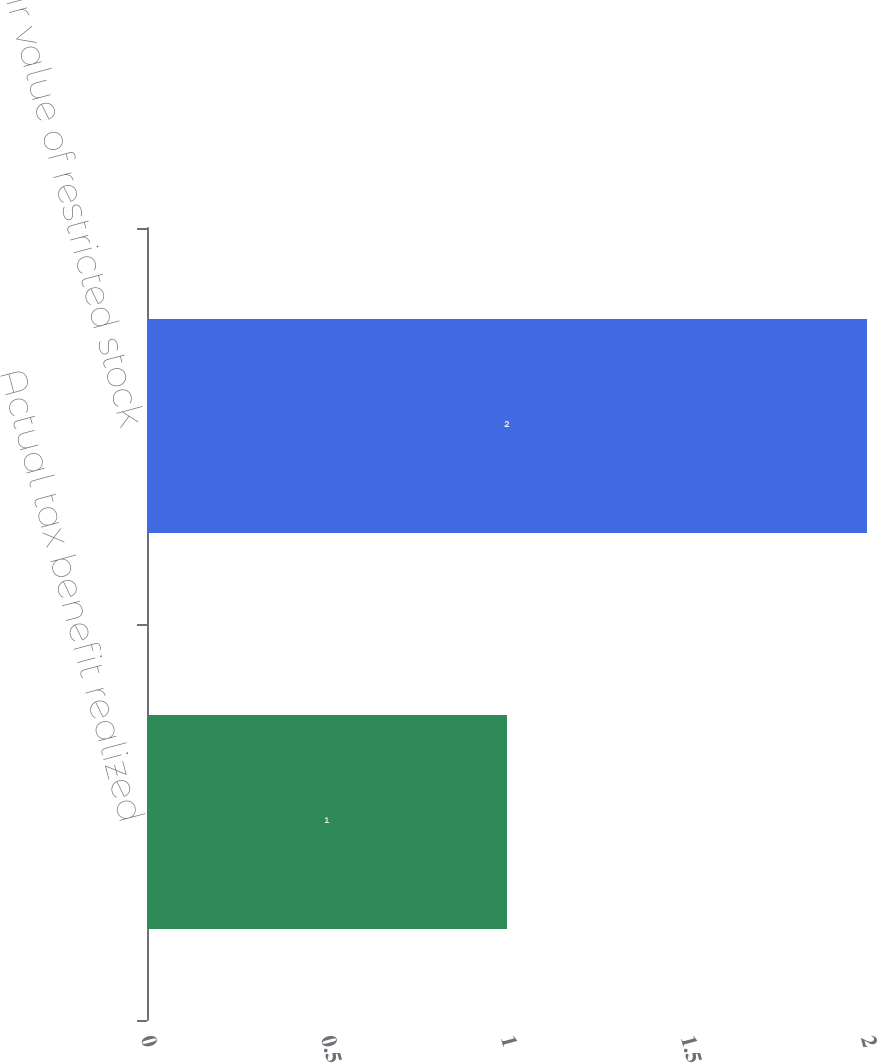<chart> <loc_0><loc_0><loc_500><loc_500><bar_chart><fcel>Actual tax benefit realized<fcel>Fair value of restricted stock<nl><fcel>1<fcel>2<nl></chart> 